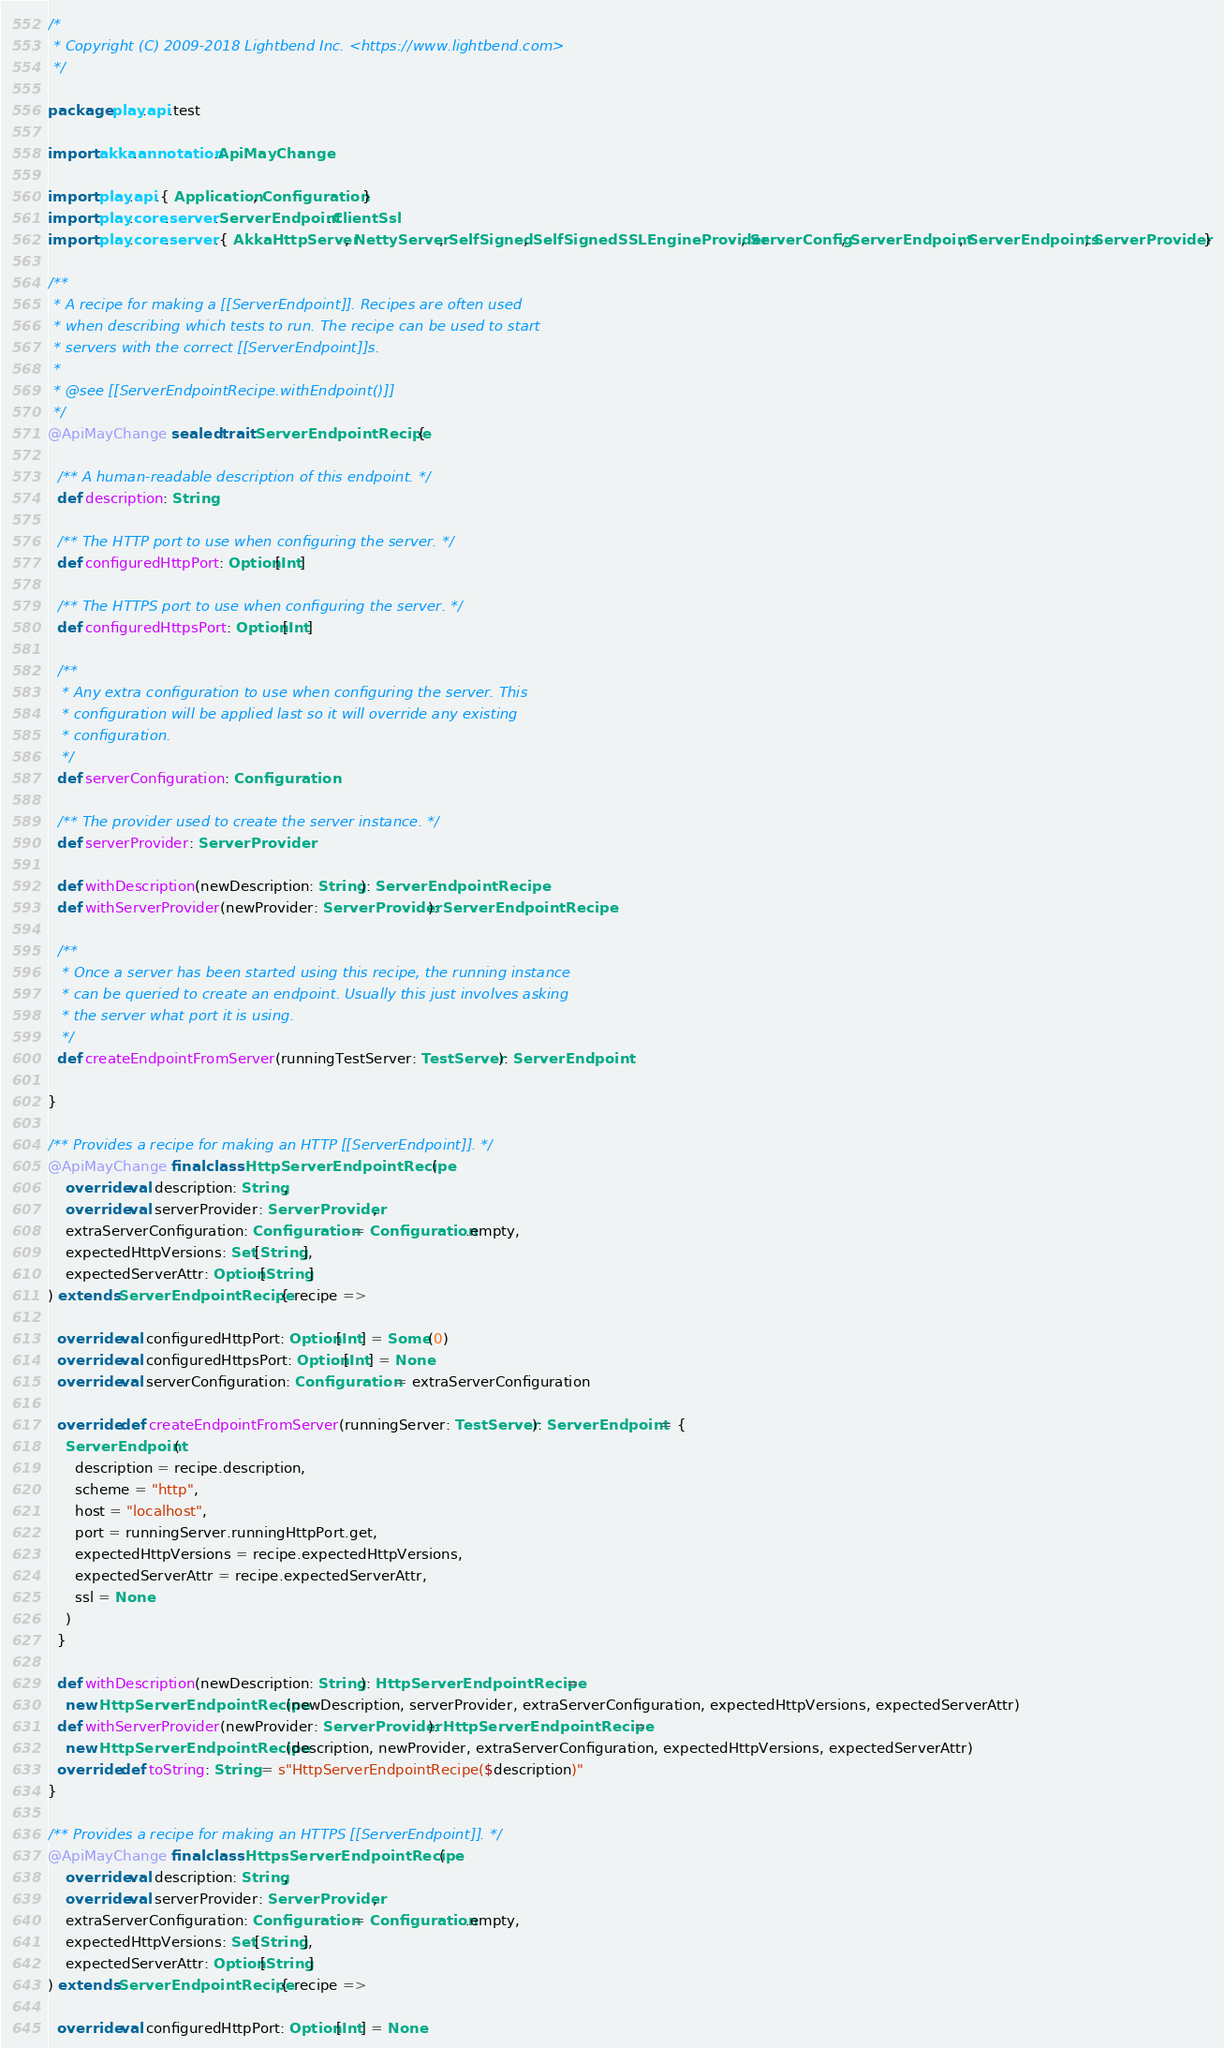Convert code to text. <code><loc_0><loc_0><loc_500><loc_500><_Scala_>/*
 * Copyright (C) 2009-2018 Lightbend Inc. <https://www.lightbend.com>
 */

package play.api.test

import akka.annotation.ApiMayChange

import play.api.{ Application, Configuration }
import play.core.server.ServerEndpoint.ClientSsl
import play.core.server.{ AkkaHttpServer, NettyServer, SelfSigned, SelfSignedSSLEngineProvider, ServerConfig, ServerEndpoint, ServerEndpoints, ServerProvider }

/**
 * A recipe for making a [[ServerEndpoint]]. Recipes are often used
 * when describing which tests to run. The recipe can be used to start
 * servers with the correct [[ServerEndpoint]]s.
 *
 * @see [[ServerEndpointRecipe.withEndpoint()]]
 */
@ApiMayChange sealed trait ServerEndpointRecipe {

  /** A human-readable description of this endpoint. */
  def description: String

  /** The HTTP port to use when configuring the server. */
  def configuredHttpPort: Option[Int]

  /** The HTTPS port to use when configuring the server. */
  def configuredHttpsPort: Option[Int]

  /**
   * Any extra configuration to use when configuring the server. This
   * configuration will be applied last so it will override any existing
   * configuration.
   */
  def serverConfiguration: Configuration

  /** The provider used to create the server instance. */
  def serverProvider: ServerProvider

  def withDescription(newDescription: String): ServerEndpointRecipe
  def withServerProvider(newProvider: ServerProvider): ServerEndpointRecipe

  /**
   * Once a server has been started using this recipe, the running instance
   * can be queried to create an endpoint. Usually this just involves asking
   * the server what port it is using.
   */
  def createEndpointFromServer(runningTestServer: TestServer): ServerEndpoint

}

/** Provides a recipe for making an HTTP [[ServerEndpoint]]. */
@ApiMayChange final class HttpServerEndpointRecipe(
    override val description: String,
    override val serverProvider: ServerProvider,
    extraServerConfiguration: Configuration = Configuration.empty,
    expectedHttpVersions: Set[String],
    expectedServerAttr: Option[String]
) extends ServerEndpointRecipe { recipe =>

  override val configuredHttpPort: Option[Int] = Some(0)
  override val configuredHttpsPort: Option[Int] = None
  override val serverConfiguration: Configuration = extraServerConfiguration

  override def createEndpointFromServer(runningServer: TestServer): ServerEndpoint = {
    ServerEndpoint(
      description = recipe.description,
      scheme = "http",
      host = "localhost",
      port = runningServer.runningHttpPort.get,
      expectedHttpVersions = recipe.expectedHttpVersions,
      expectedServerAttr = recipe.expectedServerAttr,
      ssl = None
    )
  }

  def withDescription(newDescription: String): HttpServerEndpointRecipe =
    new HttpServerEndpointRecipe(newDescription, serverProvider, extraServerConfiguration, expectedHttpVersions, expectedServerAttr)
  def withServerProvider(newProvider: ServerProvider): HttpServerEndpointRecipe =
    new HttpServerEndpointRecipe(description, newProvider, extraServerConfiguration, expectedHttpVersions, expectedServerAttr)
  override def toString: String = s"HttpServerEndpointRecipe($description)"
}

/** Provides a recipe for making an HTTPS [[ServerEndpoint]]. */
@ApiMayChange final class HttpsServerEndpointRecipe(
    override val description: String,
    override val serverProvider: ServerProvider,
    extraServerConfiguration: Configuration = Configuration.empty,
    expectedHttpVersions: Set[String],
    expectedServerAttr: Option[String]
) extends ServerEndpointRecipe { recipe =>

  override val configuredHttpPort: Option[Int] = None</code> 